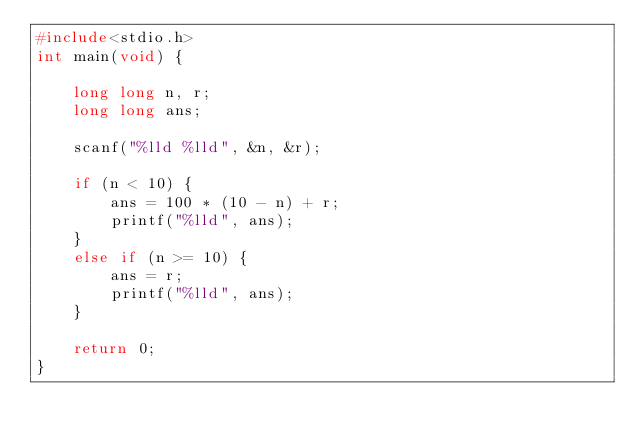Convert code to text. <code><loc_0><loc_0><loc_500><loc_500><_C_>#include<stdio.h>
int main(void) {

	long long n, r;
	long long ans;

	scanf("%lld %lld", &n, &r);

	if (n < 10) {
		ans = 100 * (10 - n) + r;
		printf("%lld", ans);
	}
	else if (n >= 10) {
		ans = r;
		printf("%lld", ans);
	}

	return 0;
}</code> 